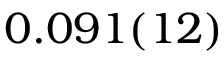<formula> <loc_0><loc_0><loc_500><loc_500>0 . 0 9 1 ( 1 2 )</formula> 